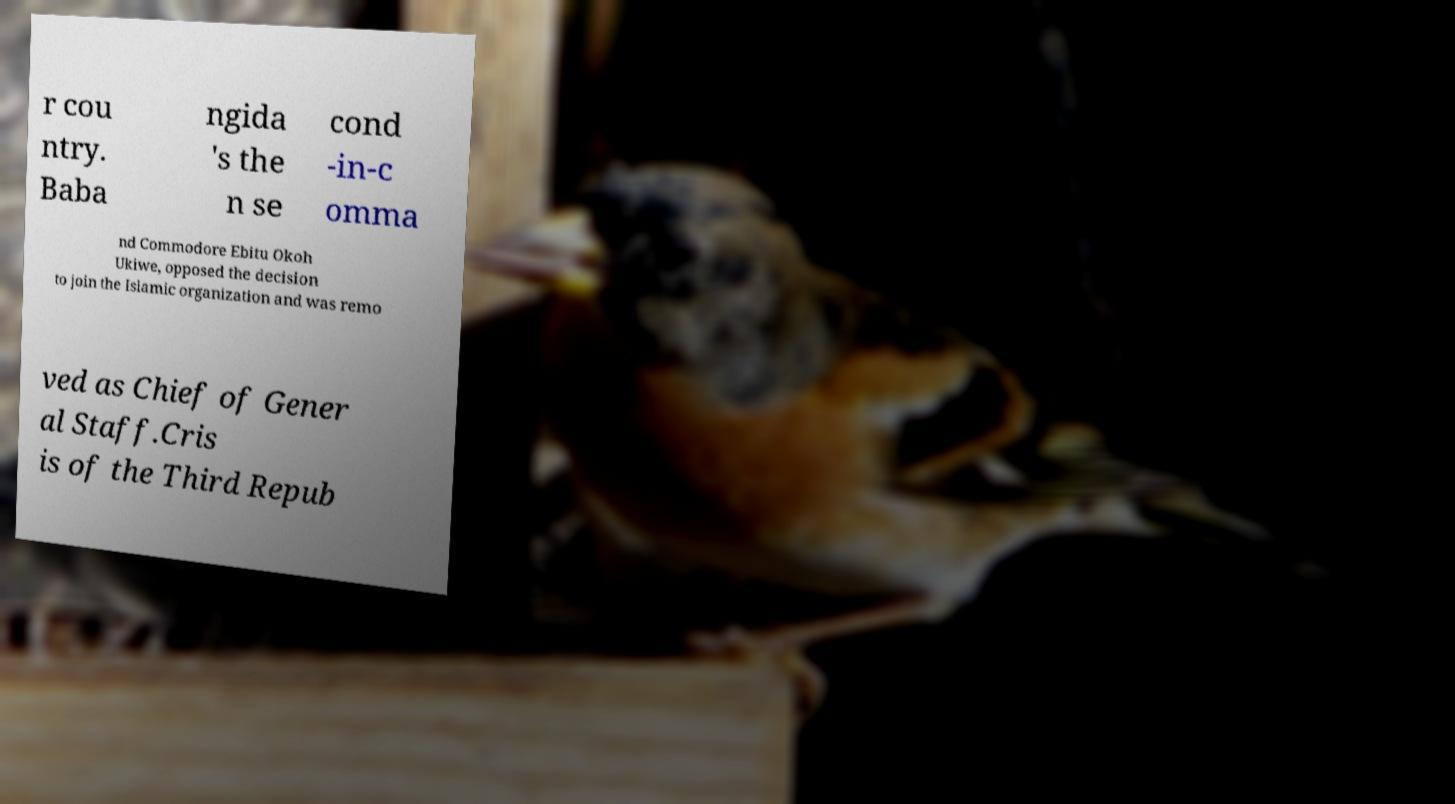Could you extract and type out the text from this image? r cou ntry. Baba ngida 's the n se cond -in-c omma nd Commodore Ebitu Okoh Ukiwe, opposed the decision to join the Islamic organization and was remo ved as Chief of Gener al Staff.Cris is of the Third Repub 